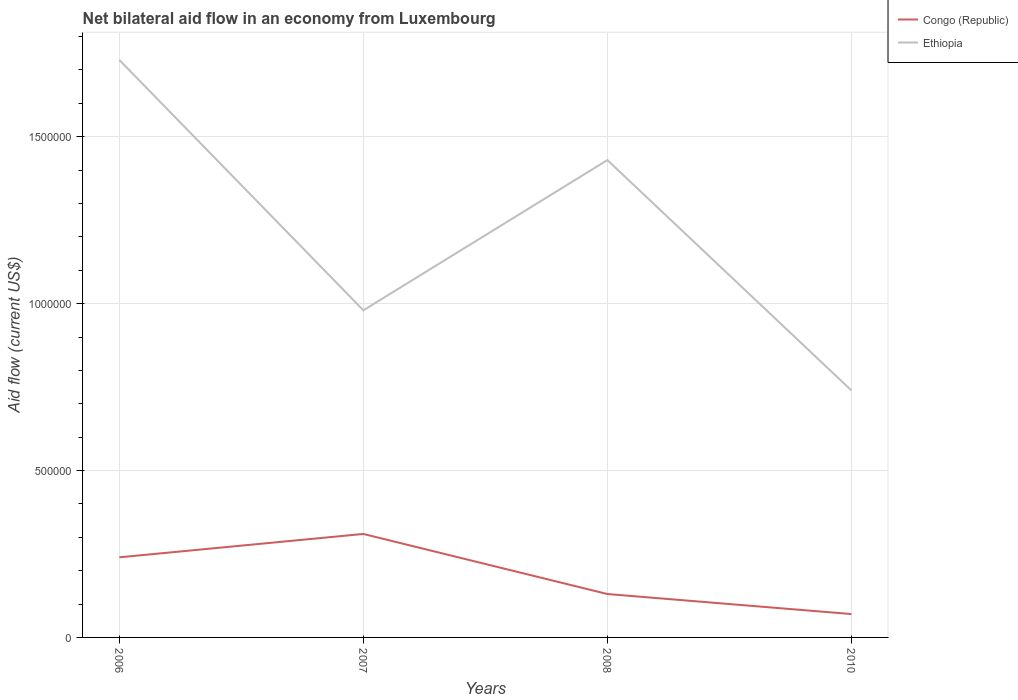Does the line corresponding to Congo (Republic) intersect with the line corresponding to Ethiopia?
Provide a succinct answer. No. What is the difference between the highest and the second highest net bilateral aid flow in Congo (Republic)?
Offer a terse response. 2.40e+05. What is the difference between the highest and the lowest net bilateral aid flow in Congo (Republic)?
Your answer should be compact. 2. How many years are there in the graph?
Provide a short and direct response. 4. What is the difference between two consecutive major ticks on the Y-axis?
Ensure brevity in your answer.  5.00e+05. Are the values on the major ticks of Y-axis written in scientific E-notation?
Keep it short and to the point. No. Does the graph contain any zero values?
Provide a succinct answer. No. Does the graph contain grids?
Ensure brevity in your answer.  Yes. How are the legend labels stacked?
Your answer should be very brief. Vertical. What is the title of the graph?
Your answer should be compact. Net bilateral aid flow in an economy from Luxembourg. What is the label or title of the X-axis?
Provide a succinct answer. Years. What is the label or title of the Y-axis?
Your answer should be compact. Aid flow (current US$). What is the Aid flow (current US$) in Congo (Republic) in 2006?
Provide a short and direct response. 2.40e+05. What is the Aid flow (current US$) in Ethiopia in 2006?
Offer a very short reply. 1.73e+06. What is the Aid flow (current US$) in Congo (Republic) in 2007?
Your answer should be very brief. 3.10e+05. What is the Aid flow (current US$) of Ethiopia in 2007?
Give a very brief answer. 9.80e+05. What is the Aid flow (current US$) in Ethiopia in 2008?
Your answer should be very brief. 1.43e+06. What is the Aid flow (current US$) in Congo (Republic) in 2010?
Offer a very short reply. 7.00e+04. What is the Aid flow (current US$) in Ethiopia in 2010?
Keep it short and to the point. 7.40e+05. Across all years, what is the maximum Aid flow (current US$) in Ethiopia?
Offer a terse response. 1.73e+06. Across all years, what is the minimum Aid flow (current US$) of Congo (Republic)?
Give a very brief answer. 7.00e+04. Across all years, what is the minimum Aid flow (current US$) in Ethiopia?
Your answer should be compact. 7.40e+05. What is the total Aid flow (current US$) in Congo (Republic) in the graph?
Your answer should be compact. 7.50e+05. What is the total Aid flow (current US$) of Ethiopia in the graph?
Provide a short and direct response. 4.88e+06. What is the difference between the Aid flow (current US$) of Congo (Republic) in 2006 and that in 2007?
Your answer should be compact. -7.00e+04. What is the difference between the Aid flow (current US$) in Ethiopia in 2006 and that in 2007?
Your answer should be very brief. 7.50e+05. What is the difference between the Aid flow (current US$) in Ethiopia in 2006 and that in 2010?
Make the answer very short. 9.90e+05. What is the difference between the Aid flow (current US$) in Congo (Republic) in 2007 and that in 2008?
Make the answer very short. 1.80e+05. What is the difference between the Aid flow (current US$) in Ethiopia in 2007 and that in 2008?
Make the answer very short. -4.50e+05. What is the difference between the Aid flow (current US$) of Congo (Republic) in 2008 and that in 2010?
Your answer should be compact. 6.00e+04. What is the difference between the Aid flow (current US$) in Ethiopia in 2008 and that in 2010?
Ensure brevity in your answer.  6.90e+05. What is the difference between the Aid flow (current US$) in Congo (Republic) in 2006 and the Aid flow (current US$) in Ethiopia in 2007?
Make the answer very short. -7.40e+05. What is the difference between the Aid flow (current US$) of Congo (Republic) in 2006 and the Aid flow (current US$) of Ethiopia in 2008?
Make the answer very short. -1.19e+06. What is the difference between the Aid flow (current US$) of Congo (Republic) in 2006 and the Aid flow (current US$) of Ethiopia in 2010?
Keep it short and to the point. -5.00e+05. What is the difference between the Aid flow (current US$) of Congo (Republic) in 2007 and the Aid flow (current US$) of Ethiopia in 2008?
Your answer should be very brief. -1.12e+06. What is the difference between the Aid flow (current US$) in Congo (Republic) in 2007 and the Aid flow (current US$) in Ethiopia in 2010?
Keep it short and to the point. -4.30e+05. What is the difference between the Aid flow (current US$) in Congo (Republic) in 2008 and the Aid flow (current US$) in Ethiopia in 2010?
Offer a terse response. -6.10e+05. What is the average Aid flow (current US$) of Congo (Republic) per year?
Offer a very short reply. 1.88e+05. What is the average Aid flow (current US$) in Ethiopia per year?
Your answer should be compact. 1.22e+06. In the year 2006, what is the difference between the Aid flow (current US$) of Congo (Republic) and Aid flow (current US$) of Ethiopia?
Your answer should be compact. -1.49e+06. In the year 2007, what is the difference between the Aid flow (current US$) in Congo (Republic) and Aid flow (current US$) in Ethiopia?
Your answer should be compact. -6.70e+05. In the year 2008, what is the difference between the Aid flow (current US$) in Congo (Republic) and Aid flow (current US$) in Ethiopia?
Offer a very short reply. -1.30e+06. In the year 2010, what is the difference between the Aid flow (current US$) in Congo (Republic) and Aid flow (current US$) in Ethiopia?
Offer a very short reply. -6.70e+05. What is the ratio of the Aid flow (current US$) in Congo (Republic) in 2006 to that in 2007?
Provide a short and direct response. 0.77. What is the ratio of the Aid flow (current US$) of Ethiopia in 2006 to that in 2007?
Ensure brevity in your answer.  1.77. What is the ratio of the Aid flow (current US$) of Congo (Republic) in 2006 to that in 2008?
Offer a terse response. 1.85. What is the ratio of the Aid flow (current US$) in Ethiopia in 2006 to that in 2008?
Ensure brevity in your answer.  1.21. What is the ratio of the Aid flow (current US$) in Congo (Republic) in 2006 to that in 2010?
Provide a succinct answer. 3.43. What is the ratio of the Aid flow (current US$) of Ethiopia in 2006 to that in 2010?
Provide a succinct answer. 2.34. What is the ratio of the Aid flow (current US$) of Congo (Republic) in 2007 to that in 2008?
Provide a short and direct response. 2.38. What is the ratio of the Aid flow (current US$) in Ethiopia in 2007 to that in 2008?
Provide a succinct answer. 0.69. What is the ratio of the Aid flow (current US$) in Congo (Republic) in 2007 to that in 2010?
Provide a short and direct response. 4.43. What is the ratio of the Aid flow (current US$) of Ethiopia in 2007 to that in 2010?
Your answer should be compact. 1.32. What is the ratio of the Aid flow (current US$) in Congo (Republic) in 2008 to that in 2010?
Offer a very short reply. 1.86. What is the ratio of the Aid flow (current US$) of Ethiopia in 2008 to that in 2010?
Offer a very short reply. 1.93. What is the difference between the highest and the lowest Aid flow (current US$) of Ethiopia?
Your answer should be very brief. 9.90e+05. 